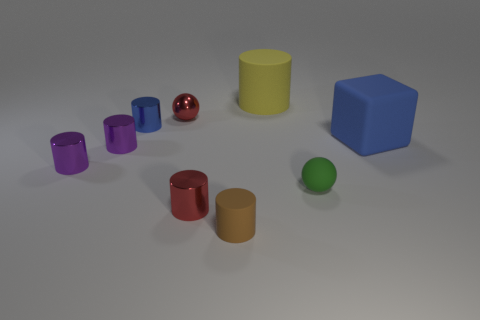How many purple cylinders must be subtracted to get 1 purple cylinders? 1 Subtract 2 cylinders. How many cylinders are left? 4 Subtract all brown cylinders. How many cylinders are left? 5 Subtract all small purple cylinders. How many cylinders are left? 4 Add 1 large blue spheres. How many objects exist? 10 Subtract all green cylinders. Subtract all gray cubes. How many cylinders are left? 6 Subtract all cubes. How many objects are left? 8 Subtract 0 gray blocks. How many objects are left? 9 Subtract all small blue metal cylinders. Subtract all small green things. How many objects are left? 7 Add 5 yellow cylinders. How many yellow cylinders are left? 6 